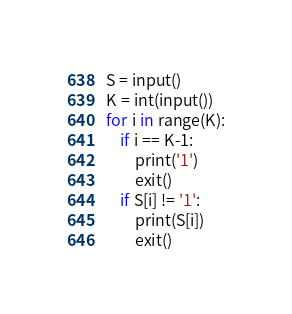<code> <loc_0><loc_0><loc_500><loc_500><_Python_>S = input()
K = int(input())
for i in range(K):
    if i == K-1:
        print('1')
        exit()
    if S[i] != '1':
        print(S[i])
        exit()
</code> 